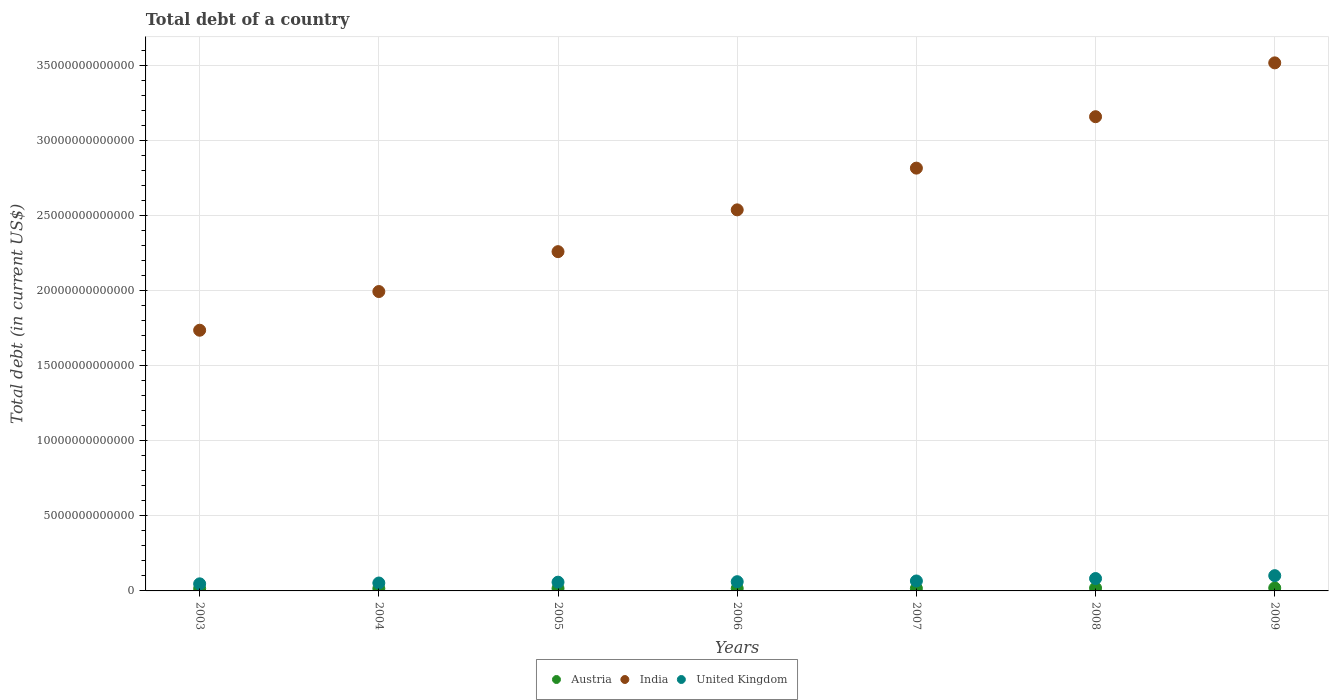How many different coloured dotlines are there?
Your answer should be very brief. 3. Is the number of dotlines equal to the number of legend labels?
Ensure brevity in your answer.  Yes. What is the debt in India in 2006?
Your answer should be compact. 2.54e+13. Across all years, what is the maximum debt in United Kingdom?
Ensure brevity in your answer.  1.02e+12. Across all years, what is the minimum debt in United Kingdom?
Offer a terse response. 4.72e+11. In which year was the debt in Austria maximum?
Provide a succinct answer. 2009. In which year was the debt in United Kingdom minimum?
Offer a very short reply. 2003. What is the total debt in India in the graph?
Make the answer very short. 1.80e+14. What is the difference between the debt in United Kingdom in 2003 and that in 2005?
Provide a short and direct response. -1.10e+11. What is the difference between the debt in United Kingdom in 2006 and the debt in India in 2003?
Make the answer very short. -1.68e+13. What is the average debt in India per year?
Give a very brief answer. 2.57e+13. In the year 2008, what is the difference between the debt in India and debt in Austria?
Make the answer very short. 3.14e+13. In how many years, is the debt in Austria greater than 23000000000000 US$?
Your answer should be very brief. 0. What is the ratio of the debt in India in 2007 to that in 2008?
Offer a terse response. 0.89. Is the debt in Austria in 2003 less than that in 2008?
Ensure brevity in your answer.  Yes. Is the difference between the debt in India in 2003 and 2005 greater than the difference between the debt in Austria in 2003 and 2005?
Provide a short and direct response. No. What is the difference between the highest and the second highest debt in Austria?
Give a very brief answer. 1.02e+1. What is the difference between the highest and the lowest debt in United Kingdom?
Provide a succinct answer. 5.44e+11. In how many years, is the debt in Austria greater than the average debt in Austria taken over all years?
Offer a very short reply. 2. Does the debt in United Kingdom monotonically increase over the years?
Make the answer very short. Yes. Is the debt in India strictly greater than the debt in Austria over the years?
Keep it short and to the point. Yes. How many dotlines are there?
Ensure brevity in your answer.  3. What is the difference between two consecutive major ticks on the Y-axis?
Your answer should be very brief. 5.00e+12. Does the graph contain grids?
Your answer should be very brief. Yes. How many legend labels are there?
Offer a terse response. 3. What is the title of the graph?
Your answer should be very brief. Total debt of a country. What is the label or title of the Y-axis?
Your answer should be compact. Total debt (in current US$). What is the Total debt (in current US$) in Austria in 2003?
Your response must be concise. 1.51e+11. What is the Total debt (in current US$) of India in 2003?
Provide a short and direct response. 1.74e+13. What is the Total debt (in current US$) in United Kingdom in 2003?
Give a very brief answer. 4.72e+11. What is the Total debt (in current US$) in Austria in 2004?
Your response must be concise. 1.57e+11. What is the Total debt (in current US$) of India in 2004?
Ensure brevity in your answer.  1.99e+13. What is the Total debt (in current US$) of United Kingdom in 2004?
Your answer should be very brief. 5.28e+11. What is the Total debt (in current US$) of Austria in 2005?
Provide a succinct answer. 1.66e+11. What is the Total debt (in current US$) of India in 2005?
Your answer should be very brief. 2.26e+13. What is the Total debt (in current US$) in United Kingdom in 2005?
Keep it short and to the point. 5.83e+11. What is the Total debt (in current US$) of Austria in 2006?
Make the answer very short. 1.65e+11. What is the Total debt (in current US$) of India in 2006?
Provide a short and direct response. 2.54e+13. What is the Total debt (in current US$) in United Kingdom in 2006?
Give a very brief answer. 6.15e+11. What is the Total debt (in current US$) in Austria in 2007?
Your answer should be very brief. 1.67e+11. What is the Total debt (in current US$) of India in 2007?
Your response must be concise. 2.82e+13. What is the Total debt (in current US$) in United Kingdom in 2007?
Give a very brief answer. 6.63e+11. What is the Total debt (in current US$) of Austria in 2008?
Your answer should be very brief. 1.87e+11. What is the Total debt (in current US$) in India in 2008?
Provide a short and direct response. 3.16e+13. What is the Total debt (in current US$) in United Kingdom in 2008?
Your answer should be compact. 8.25e+11. What is the Total debt (in current US$) in Austria in 2009?
Offer a very short reply. 1.97e+11. What is the Total debt (in current US$) of India in 2009?
Keep it short and to the point. 3.52e+13. What is the Total debt (in current US$) of United Kingdom in 2009?
Offer a terse response. 1.02e+12. Across all years, what is the maximum Total debt (in current US$) in Austria?
Ensure brevity in your answer.  1.97e+11. Across all years, what is the maximum Total debt (in current US$) in India?
Give a very brief answer. 3.52e+13. Across all years, what is the maximum Total debt (in current US$) of United Kingdom?
Ensure brevity in your answer.  1.02e+12. Across all years, what is the minimum Total debt (in current US$) of Austria?
Offer a very short reply. 1.51e+11. Across all years, what is the minimum Total debt (in current US$) in India?
Your answer should be very brief. 1.74e+13. Across all years, what is the minimum Total debt (in current US$) of United Kingdom?
Your answer should be very brief. 4.72e+11. What is the total Total debt (in current US$) in Austria in the graph?
Give a very brief answer. 1.19e+12. What is the total Total debt (in current US$) of India in the graph?
Offer a very short reply. 1.80e+14. What is the total Total debt (in current US$) in United Kingdom in the graph?
Keep it short and to the point. 4.70e+12. What is the difference between the Total debt (in current US$) in Austria in 2003 and that in 2004?
Keep it short and to the point. -6.16e+09. What is the difference between the Total debt (in current US$) of India in 2003 and that in 2004?
Your answer should be compact. -2.58e+12. What is the difference between the Total debt (in current US$) in United Kingdom in 2003 and that in 2004?
Ensure brevity in your answer.  -5.53e+1. What is the difference between the Total debt (in current US$) in Austria in 2003 and that in 2005?
Provide a succinct answer. -1.45e+1. What is the difference between the Total debt (in current US$) of India in 2003 and that in 2005?
Your answer should be very brief. -5.23e+12. What is the difference between the Total debt (in current US$) in United Kingdom in 2003 and that in 2005?
Give a very brief answer. -1.10e+11. What is the difference between the Total debt (in current US$) in Austria in 2003 and that in 2006?
Provide a succinct answer. -1.43e+1. What is the difference between the Total debt (in current US$) of India in 2003 and that in 2006?
Keep it short and to the point. -8.02e+12. What is the difference between the Total debt (in current US$) in United Kingdom in 2003 and that in 2006?
Provide a succinct answer. -1.42e+11. What is the difference between the Total debt (in current US$) of Austria in 2003 and that in 2007?
Provide a succinct answer. -1.55e+1. What is the difference between the Total debt (in current US$) of India in 2003 and that in 2007?
Ensure brevity in your answer.  -1.08e+13. What is the difference between the Total debt (in current US$) in United Kingdom in 2003 and that in 2007?
Your response must be concise. -1.91e+11. What is the difference between the Total debt (in current US$) of Austria in 2003 and that in 2008?
Your response must be concise. -3.62e+1. What is the difference between the Total debt (in current US$) of India in 2003 and that in 2008?
Offer a very short reply. -1.42e+13. What is the difference between the Total debt (in current US$) of United Kingdom in 2003 and that in 2008?
Your response must be concise. -3.53e+11. What is the difference between the Total debt (in current US$) in Austria in 2003 and that in 2009?
Your answer should be compact. -4.64e+1. What is the difference between the Total debt (in current US$) of India in 2003 and that in 2009?
Ensure brevity in your answer.  -1.78e+13. What is the difference between the Total debt (in current US$) of United Kingdom in 2003 and that in 2009?
Your answer should be compact. -5.44e+11. What is the difference between the Total debt (in current US$) of Austria in 2004 and that in 2005?
Give a very brief answer. -8.31e+09. What is the difference between the Total debt (in current US$) of India in 2004 and that in 2005?
Provide a short and direct response. -2.66e+12. What is the difference between the Total debt (in current US$) of United Kingdom in 2004 and that in 2005?
Provide a succinct answer. -5.50e+1. What is the difference between the Total debt (in current US$) in Austria in 2004 and that in 2006?
Provide a succinct answer. -8.10e+09. What is the difference between the Total debt (in current US$) in India in 2004 and that in 2006?
Ensure brevity in your answer.  -5.44e+12. What is the difference between the Total debt (in current US$) in United Kingdom in 2004 and that in 2006?
Your response must be concise. -8.70e+1. What is the difference between the Total debt (in current US$) of Austria in 2004 and that in 2007?
Keep it short and to the point. -9.38e+09. What is the difference between the Total debt (in current US$) in India in 2004 and that in 2007?
Provide a succinct answer. -8.22e+12. What is the difference between the Total debt (in current US$) in United Kingdom in 2004 and that in 2007?
Offer a very short reply. -1.35e+11. What is the difference between the Total debt (in current US$) in Austria in 2004 and that in 2008?
Offer a very short reply. -3.00e+1. What is the difference between the Total debt (in current US$) in India in 2004 and that in 2008?
Ensure brevity in your answer.  -1.16e+13. What is the difference between the Total debt (in current US$) of United Kingdom in 2004 and that in 2008?
Your answer should be compact. -2.98e+11. What is the difference between the Total debt (in current US$) of Austria in 2004 and that in 2009?
Your answer should be very brief. -4.02e+1. What is the difference between the Total debt (in current US$) of India in 2004 and that in 2009?
Keep it short and to the point. -1.52e+13. What is the difference between the Total debt (in current US$) in United Kingdom in 2004 and that in 2009?
Ensure brevity in your answer.  -4.89e+11. What is the difference between the Total debt (in current US$) of Austria in 2005 and that in 2006?
Your answer should be very brief. 2.14e+08. What is the difference between the Total debt (in current US$) in India in 2005 and that in 2006?
Your response must be concise. -2.78e+12. What is the difference between the Total debt (in current US$) of United Kingdom in 2005 and that in 2006?
Make the answer very short. -3.20e+1. What is the difference between the Total debt (in current US$) in Austria in 2005 and that in 2007?
Your response must be concise. -1.07e+09. What is the difference between the Total debt (in current US$) in India in 2005 and that in 2007?
Make the answer very short. -5.56e+12. What is the difference between the Total debt (in current US$) in United Kingdom in 2005 and that in 2007?
Make the answer very short. -8.05e+1. What is the difference between the Total debt (in current US$) in Austria in 2005 and that in 2008?
Keep it short and to the point. -2.17e+1. What is the difference between the Total debt (in current US$) in India in 2005 and that in 2008?
Make the answer very short. -8.99e+12. What is the difference between the Total debt (in current US$) in United Kingdom in 2005 and that in 2008?
Your response must be concise. -2.43e+11. What is the difference between the Total debt (in current US$) in Austria in 2005 and that in 2009?
Give a very brief answer. -3.19e+1. What is the difference between the Total debt (in current US$) of India in 2005 and that in 2009?
Make the answer very short. -1.26e+13. What is the difference between the Total debt (in current US$) in United Kingdom in 2005 and that in 2009?
Offer a terse response. -4.34e+11. What is the difference between the Total debt (in current US$) in Austria in 2006 and that in 2007?
Provide a short and direct response. -1.28e+09. What is the difference between the Total debt (in current US$) in India in 2006 and that in 2007?
Provide a succinct answer. -2.78e+12. What is the difference between the Total debt (in current US$) of United Kingdom in 2006 and that in 2007?
Your answer should be compact. -4.85e+1. What is the difference between the Total debt (in current US$) of Austria in 2006 and that in 2008?
Offer a very short reply. -2.19e+1. What is the difference between the Total debt (in current US$) of India in 2006 and that in 2008?
Provide a succinct answer. -6.21e+12. What is the difference between the Total debt (in current US$) of United Kingdom in 2006 and that in 2008?
Provide a short and direct response. -2.11e+11. What is the difference between the Total debt (in current US$) of Austria in 2006 and that in 2009?
Keep it short and to the point. -3.21e+1. What is the difference between the Total debt (in current US$) of India in 2006 and that in 2009?
Your answer should be compact. -9.79e+12. What is the difference between the Total debt (in current US$) in United Kingdom in 2006 and that in 2009?
Your answer should be very brief. -4.02e+11. What is the difference between the Total debt (in current US$) of Austria in 2007 and that in 2008?
Your response must be concise. -2.06e+1. What is the difference between the Total debt (in current US$) of India in 2007 and that in 2008?
Your answer should be compact. -3.43e+12. What is the difference between the Total debt (in current US$) of United Kingdom in 2007 and that in 2008?
Make the answer very short. -1.62e+11. What is the difference between the Total debt (in current US$) of Austria in 2007 and that in 2009?
Offer a very short reply. -3.08e+1. What is the difference between the Total debt (in current US$) in India in 2007 and that in 2009?
Provide a short and direct response. -7.01e+12. What is the difference between the Total debt (in current US$) in United Kingdom in 2007 and that in 2009?
Keep it short and to the point. -3.54e+11. What is the difference between the Total debt (in current US$) in Austria in 2008 and that in 2009?
Give a very brief answer. -1.02e+1. What is the difference between the Total debt (in current US$) of India in 2008 and that in 2009?
Your response must be concise. -3.59e+12. What is the difference between the Total debt (in current US$) in United Kingdom in 2008 and that in 2009?
Your response must be concise. -1.91e+11. What is the difference between the Total debt (in current US$) of Austria in 2003 and the Total debt (in current US$) of India in 2004?
Provide a short and direct response. -1.98e+13. What is the difference between the Total debt (in current US$) in Austria in 2003 and the Total debt (in current US$) in United Kingdom in 2004?
Offer a terse response. -3.77e+11. What is the difference between the Total debt (in current US$) in India in 2003 and the Total debt (in current US$) in United Kingdom in 2004?
Your answer should be very brief. 1.68e+13. What is the difference between the Total debt (in current US$) in Austria in 2003 and the Total debt (in current US$) in India in 2005?
Keep it short and to the point. -2.25e+13. What is the difference between the Total debt (in current US$) in Austria in 2003 and the Total debt (in current US$) in United Kingdom in 2005?
Provide a short and direct response. -4.32e+11. What is the difference between the Total debt (in current US$) of India in 2003 and the Total debt (in current US$) of United Kingdom in 2005?
Make the answer very short. 1.68e+13. What is the difference between the Total debt (in current US$) in Austria in 2003 and the Total debt (in current US$) in India in 2006?
Provide a succinct answer. -2.52e+13. What is the difference between the Total debt (in current US$) of Austria in 2003 and the Total debt (in current US$) of United Kingdom in 2006?
Your answer should be compact. -4.64e+11. What is the difference between the Total debt (in current US$) of India in 2003 and the Total debt (in current US$) of United Kingdom in 2006?
Your response must be concise. 1.68e+13. What is the difference between the Total debt (in current US$) in Austria in 2003 and the Total debt (in current US$) in India in 2007?
Offer a terse response. -2.80e+13. What is the difference between the Total debt (in current US$) of Austria in 2003 and the Total debt (in current US$) of United Kingdom in 2007?
Ensure brevity in your answer.  -5.12e+11. What is the difference between the Total debt (in current US$) in India in 2003 and the Total debt (in current US$) in United Kingdom in 2007?
Provide a short and direct response. 1.67e+13. What is the difference between the Total debt (in current US$) of Austria in 2003 and the Total debt (in current US$) of India in 2008?
Ensure brevity in your answer.  -3.14e+13. What is the difference between the Total debt (in current US$) in Austria in 2003 and the Total debt (in current US$) in United Kingdom in 2008?
Provide a short and direct response. -6.74e+11. What is the difference between the Total debt (in current US$) of India in 2003 and the Total debt (in current US$) of United Kingdom in 2008?
Offer a very short reply. 1.65e+13. What is the difference between the Total debt (in current US$) in Austria in 2003 and the Total debt (in current US$) in India in 2009?
Provide a succinct answer. -3.50e+13. What is the difference between the Total debt (in current US$) of Austria in 2003 and the Total debt (in current US$) of United Kingdom in 2009?
Ensure brevity in your answer.  -8.66e+11. What is the difference between the Total debt (in current US$) of India in 2003 and the Total debt (in current US$) of United Kingdom in 2009?
Offer a terse response. 1.64e+13. What is the difference between the Total debt (in current US$) of Austria in 2004 and the Total debt (in current US$) of India in 2005?
Keep it short and to the point. -2.24e+13. What is the difference between the Total debt (in current US$) of Austria in 2004 and the Total debt (in current US$) of United Kingdom in 2005?
Make the answer very short. -4.25e+11. What is the difference between the Total debt (in current US$) of India in 2004 and the Total debt (in current US$) of United Kingdom in 2005?
Offer a very short reply. 1.94e+13. What is the difference between the Total debt (in current US$) of Austria in 2004 and the Total debt (in current US$) of India in 2006?
Make the answer very short. -2.52e+13. What is the difference between the Total debt (in current US$) of Austria in 2004 and the Total debt (in current US$) of United Kingdom in 2006?
Keep it short and to the point. -4.57e+11. What is the difference between the Total debt (in current US$) in India in 2004 and the Total debt (in current US$) in United Kingdom in 2006?
Make the answer very short. 1.93e+13. What is the difference between the Total debt (in current US$) in Austria in 2004 and the Total debt (in current US$) in India in 2007?
Your answer should be very brief. -2.80e+13. What is the difference between the Total debt (in current US$) in Austria in 2004 and the Total debt (in current US$) in United Kingdom in 2007?
Offer a very short reply. -5.06e+11. What is the difference between the Total debt (in current US$) in India in 2004 and the Total debt (in current US$) in United Kingdom in 2007?
Provide a short and direct response. 1.93e+13. What is the difference between the Total debt (in current US$) in Austria in 2004 and the Total debt (in current US$) in India in 2008?
Your answer should be compact. -3.14e+13. What is the difference between the Total debt (in current US$) in Austria in 2004 and the Total debt (in current US$) in United Kingdom in 2008?
Give a very brief answer. -6.68e+11. What is the difference between the Total debt (in current US$) of India in 2004 and the Total debt (in current US$) of United Kingdom in 2008?
Keep it short and to the point. 1.91e+13. What is the difference between the Total debt (in current US$) of Austria in 2004 and the Total debt (in current US$) of India in 2009?
Provide a short and direct response. -3.50e+13. What is the difference between the Total debt (in current US$) of Austria in 2004 and the Total debt (in current US$) of United Kingdom in 2009?
Provide a succinct answer. -8.59e+11. What is the difference between the Total debt (in current US$) of India in 2004 and the Total debt (in current US$) of United Kingdom in 2009?
Provide a short and direct response. 1.89e+13. What is the difference between the Total debt (in current US$) in Austria in 2005 and the Total debt (in current US$) in India in 2006?
Give a very brief answer. -2.52e+13. What is the difference between the Total debt (in current US$) of Austria in 2005 and the Total debt (in current US$) of United Kingdom in 2006?
Provide a succinct answer. -4.49e+11. What is the difference between the Total debt (in current US$) in India in 2005 and the Total debt (in current US$) in United Kingdom in 2006?
Your response must be concise. 2.20e+13. What is the difference between the Total debt (in current US$) in Austria in 2005 and the Total debt (in current US$) in India in 2007?
Offer a terse response. -2.80e+13. What is the difference between the Total debt (in current US$) of Austria in 2005 and the Total debt (in current US$) of United Kingdom in 2007?
Give a very brief answer. -4.98e+11. What is the difference between the Total debt (in current US$) in India in 2005 and the Total debt (in current US$) in United Kingdom in 2007?
Your response must be concise. 2.19e+13. What is the difference between the Total debt (in current US$) in Austria in 2005 and the Total debt (in current US$) in India in 2008?
Provide a short and direct response. -3.14e+13. What is the difference between the Total debt (in current US$) of Austria in 2005 and the Total debt (in current US$) of United Kingdom in 2008?
Ensure brevity in your answer.  -6.60e+11. What is the difference between the Total debt (in current US$) in India in 2005 and the Total debt (in current US$) in United Kingdom in 2008?
Provide a short and direct response. 2.18e+13. What is the difference between the Total debt (in current US$) in Austria in 2005 and the Total debt (in current US$) in India in 2009?
Ensure brevity in your answer.  -3.50e+13. What is the difference between the Total debt (in current US$) of Austria in 2005 and the Total debt (in current US$) of United Kingdom in 2009?
Ensure brevity in your answer.  -8.51e+11. What is the difference between the Total debt (in current US$) of India in 2005 and the Total debt (in current US$) of United Kingdom in 2009?
Give a very brief answer. 2.16e+13. What is the difference between the Total debt (in current US$) in Austria in 2006 and the Total debt (in current US$) in India in 2007?
Your answer should be compact. -2.80e+13. What is the difference between the Total debt (in current US$) in Austria in 2006 and the Total debt (in current US$) in United Kingdom in 2007?
Your answer should be very brief. -4.98e+11. What is the difference between the Total debt (in current US$) in India in 2006 and the Total debt (in current US$) in United Kingdom in 2007?
Keep it short and to the point. 2.47e+13. What is the difference between the Total debt (in current US$) of Austria in 2006 and the Total debt (in current US$) of India in 2008?
Ensure brevity in your answer.  -3.14e+13. What is the difference between the Total debt (in current US$) of Austria in 2006 and the Total debt (in current US$) of United Kingdom in 2008?
Keep it short and to the point. -6.60e+11. What is the difference between the Total debt (in current US$) of India in 2006 and the Total debt (in current US$) of United Kingdom in 2008?
Your answer should be very brief. 2.46e+13. What is the difference between the Total debt (in current US$) of Austria in 2006 and the Total debt (in current US$) of India in 2009?
Your answer should be very brief. -3.50e+13. What is the difference between the Total debt (in current US$) in Austria in 2006 and the Total debt (in current US$) in United Kingdom in 2009?
Provide a short and direct response. -8.51e+11. What is the difference between the Total debt (in current US$) of India in 2006 and the Total debt (in current US$) of United Kingdom in 2009?
Offer a terse response. 2.44e+13. What is the difference between the Total debt (in current US$) in Austria in 2007 and the Total debt (in current US$) in India in 2008?
Provide a short and direct response. -3.14e+13. What is the difference between the Total debt (in current US$) of Austria in 2007 and the Total debt (in current US$) of United Kingdom in 2008?
Provide a short and direct response. -6.59e+11. What is the difference between the Total debt (in current US$) of India in 2007 and the Total debt (in current US$) of United Kingdom in 2008?
Give a very brief answer. 2.73e+13. What is the difference between the Total debt (in current US$) in Austria in 2007 and the Total debt (in current US$) in India in 2009?
Provide a succinct answer. -3.50e+13. What is the difference between the Total debt (in current US$) in Austria in 2007 and the Total debt (in current US$) in United Kingdom in 2009?
Provide a short and direct response. -8.50e+11. What is the difference between the Total debt (in current US$) in India in 2007 and the Total debt (in current US$) in United Kingdom in 2009?
Offer a very short reply. 2.71e+13. What is the difference between the Total debt (in current US$) in Austria in 2008 and the Total debt (in current US$) in India in 2009?
Give a very brief answer. -3.50e+13. What is the difference between the Total debt (in current US$) in Austria in 2008 and the Total debt (in current US$) in United Kingdom in 2009?
Ensure brevity in your answer.  -8.29e+11. What is the difference between the Total debt (in current US$) in India in 2008 and the Total debt (in current US$) in United Kingdom in 2009?
Provide a succinct answer. 3.06e+13. What is the average Total debt (in current US$) of Austria per year?
Give a very brief answer. 1.70e+11. What is the average Total debt (in current US$) of India per year?
Your answer should be compact. 2.57e+13. What is the average Total debt (in current US$) of United Kingdom per year?
Ensure brevity in your answer.  6.72e+11. In the year 2003, what is the difference between the Total debt (in current US$) in Austria and Total debt (in current US$) in India?
Keep it short and to the point. -1.72e+13. In the year 2003, what is the difference between the Total debt (in current US$) in Austria and Total debt (in current US$) in United Kingdom?
Provide a short and direct response. -3.21e+11. In the year 2003, what is the difference between the Total debt (in current US$) in India and Total debt (in current US$) in United Kingdom?
Ensure brevity in your answer.  1.69e+13. In the year 2004, what is the difference between the Total debt (in current US$) of Austria and Total debt (in current US$) of India?
Ensure brevity in your answer.  -1.98e+13. In the year 2004, what is the difference between the Total debt (in current US$) of Austria and Total debt (in current US$) of United Kingdom?
Make the answer very short. -3.70e+11. In the year 2004, what is the difference between the Total debt (in current US$) in India and Total debt (in current US$) in United Kingdom?
Keep it short and to the point. 1.94e+13. In the year 2005, what is the difference between the Total debt (in current US$) of Austria and Total debt (in current US$) of India?
Keep it short and to the point. -2.24e+13. In the year 2005, what is the difference between the Total debt (in current US$) in Austria and Total debt (in current US$) in United Kingdom?
Make the answer very short. -4.17e+11. In the year 2005, what is the difference between the Total debt (in current US$) in India and Total debt (in current US$) in United Kingdom?
Your answer should be very brief. 2.20e+13. In the year 2006, what is the difference between the Total debt (in current US$) in Austria and Total debt (in current US$) in India?
Offer a terse response. -2.52e+13. In the year 2006, what is the difference between the Total debt (in current US$) in Austria and Total debt (in current US$) in United Kingdom?
Give a very brief answer. -4.49e+11. In the year 2006, what is the difference between the Total debt (in current US$) in India and Total debt (in current US$) in United Kingdom?
Offer a very short reply. 2.48e+13. In the year 2007, what is the difference between the Total debt (in current US$) in Austria and Total debt (in current US$) in India?
Offer a very short reply. -2.80e+13. In the year 2007, what is the difference between the Total debt (in current US$) of Austria and Total debt (in current US$) of United Kingdom?
Your answer should be very brief. -4.97e+11. In the year 2007, what is the difference between the Total debt (in current US$) in India and Total debt (in current US$) in United Kingdom?
Ensure brevity in your answer.  2.75e+13. In the year 2008, what is the difference between the Total debt (in current US$) of Austria and Total debt (in current US$) of India?
Your answer should be compact. -3.14e+13. In the year 2008, what is the difference between the Total debt (in current US$) in Austria and Total debt (in current US$) in United Kingdom?
Keep it short and to the point. -6.38e+11. In the year 2008, what is the difference between the Total debt (in current US$) of India and Total debt (in current US$) of United Kingdom?
Give a very brief answer. 3.08e+13. In the year 2009, what is the difference between the Total debt (in current US$) of Austria and Total debt (in current US$) of India?
Ensure brevity in your answer.  -3.50e+13. In the year 2009, what is the difference between the Total debt (in current US$) of Austria and Total debt (in current US$) of United Kingdom?
Provide a succinct answer. -8.19e+11. In the year 2009, what is the difference between the Total debt (in current US$) in India and Total debt (in current US$) in United Kingdom?
Your answer should be compact. 3.42e+13. What is the ratio of the Total debt (in current US$) of Austria in 2003 to that in 2004?
Your response must be concise. 0.96. What is the ratio of the Total debt (in current US$) of India in 2003 to that in 2004?
Give a very brief answer. 0.87. What is the ratio of the Total debt (in current US$) in United Kingdom in 2003 to that in 2004?
Provide a short and direct response. 0.9. What is the ratio of the Total debt (in current US$) in Austria in 2003 to that in 2005?
Your answer should be very brief. 0.91. What is the ratio of the Total debt (in current US$) in India in 2003 to that in 2005?
Provide a short and direct response. 0.77. What is the ratio of the Total debt (in current US$) in United Kingdom in 2003 to that in 2005?
Make the answer very short. 0.81. What is the ratio of the Total debt (in current US$) in Austria in 2003 to that in 2006?
Offer a very short reply. 0.91. What is the ratio of the Total debt (in current US$) in India in 2003 to that in 2006?
Provide a short and direct response. 0.68. What is the ratio of the Total debt (in current US$) in United Kingdom in 2003 to that in 2006?
Provide a succinct answer. 0.77. What is the ratio of the Total debt (in current US$) in Austria in 2003 to that in 2007?
Give a very brief answer. 0.91. What is the ratio of the Total debt (in current US$) in India in 2003 to that in 2007?
Your answer should be very brief. 0.62. What is the ratio of the Total debt (in current US$) in United Kingdom in 2003 to that in 2007?
Your answer should be very brief. 0.71. What is the ratio of the Total debt (in current US$) of Austria in 2003 to that in 2008?
Your answer should be very brief. 0.81. What is the ratio of the Total debt (in current US$) of India in 2003 to that in 2008?
Provide a short and direct response. 0.55. What is the ratio of the Total debt (in current US$) in United Kingdom in 2003 to that in 2008?
Your answer should be compact. 0.57. What is the ratio of the Total debt (in current US$) in Austria in 2003 to that in 2009?
Provide a short and direct response. 0.77. What is the ratio of the Total debt (in current US$) of India in 2003 to that in 2009?
Provide a short and direct response. 0.49. What is the ratio of the Total debt (in current US$) of United Kingdom in 2003 to that in 2009?
Ensure brevity in your answer.  0.46. What is the ratio of the Total debt (in current US$) in Austria in 2004 to that in 2005?
Ensure brevity in your answer.  0.95. What is the ratio of the Total debt (in current US$) of India in 2004 to that in 2005?
Your response must be concise. 0.88. What is the ratio of the Total debt (in current US$) in United Kingdom in 2004 to that in 2005?
Ensure brevity in your answer.  0.91. What is the ratio of the Total debt (in current US$) of Austria in 2004 to that in 2006?
Keep it short and to the point. 0.95. What is the ratio of the Total debt (in current US$) in India in 2004 to that in 2006?
Offer a terse response. 0.79. What is the ratio of the Total debt (in current US$) of United Kingdom in 2004 to that in 2006?
Your answer should be compact. 0.86. What is the ratio of the Total debt (in current US$) in Austria in 2004 to that in 2007?
Keep it short and to the point. 0.94. What is the ratio of the Total debt (in current US$) in India in 2004 to that in 2007?
Ensure brevity in your answer.  0.71. What is the ratio of the Total debt (in current US$) in United Kingdom in 2004 to that in 2007?
Give a very brief answer. 0.8. What is the ratio of the Total debt (in current US$) in Austria in 2004 to that in 2008?
Your answer should be very brief. 0.84. What is the ratio of the Total debt (in current US$) in India in 2004 to that in 2008?
Provide a succinct answer. 0.63. What is the ratio of the Total debt (in current US$) of United Kingdom in 2004 to that in 2008?
Your answer should be compact. 0.64. What is the ratio of the Total debt (in current US$) of Austria in 2004 to that in 2009?
Keep it short and to the point. 0.8. What is the ratio of the Total debt (in current US$) in India in 2004 to that in 2009?
Give a very brief answer. 0.57. What is the ratio of the Total debt (in current US$) of United Kingdom in 2004 to that in 2009?
Offer a terse response. 0.52. What is the ratio of the Total debt (in current US$) in India in 2005 to that in 2006?
Provide a short and direct response. 0.89. What is the ratio of the Total debt (in current US$) of United Kingdom in 2005 to that in 2006?
Keep it short and to the point. 0.95. What is the ratio of the Total debt (in current US$) of Austria in 2005 to that in 2007?
Give a very brief answer. 0.99. What is the ratio of the Total debt (in current US$) in India in 2005 to that in 2007?
Provide a succinct answer. 0.8. What is the ratio of the Total debt (in current US$) of United Kingdom in 2005 to that in 2007?
Your answer should be very brief. 0.88. What is the ratio of the Total debt (in current US$) in Austria in 2005 to that in 2008?
Offer a very short reply. 0.88. What is the ratio of the Total debt (in current US$) of India in 2005 to that in 2008?
Offer a terse response. 0.72. What is the ratio of the Total debt (in current US$) in United Kingdom in 2005 to that in 2008?
Keep it short and to the point. 0.71. What is the ratio of the Total debt (in current US$) in Austria in 2005 to that in 2009?
Provide a short and direct response. 0.84. What is the ratio of the Total debt (in current US$) of India in 2005 to that in 2009?
Make the answer very short. 0.64. What is the ratio of the Total debt (in current US$) in United Kingdom in 2005 to that in 2009?
Make the answer very short. 0.57. What is the ratio of the Total debt (in current US$) in Austria in 2006 to that in 2007?
Provide a succinct answer. 0.99. What is the ratio of the Total debt (in current US$) in India in 2006 to that in 2007?
Your response must be concise. 0.9. What is the ratio of the Total debt (in current US$) in United Kingdom in 2006 to that in 2007?
Keep it short and to the point. 0.93. What is the ratio of the Total debt (in current US$) of Austria in 2006 to that in 2008?
Keep it short and to the point. 0.88. What is the ratio of the Total debt (in current US$) in India in 2006 to that in 2008?
Provide a short and direct response. 0.8. What is the ratio of the Total debt (in current US$) in United Kingdom in 2006 to that in 2008?
Give a very brief answer. 0.74. What is the ratio of the Total debt (in current US$) in Austria in 2006 to that in 2009?
Give a very brief answer. 0.84. What is the ratio of the Total debt (in current US$) in India in 2006 to that in 2009?
Provide a short and direct response. 0.72. What is the ratio of the Total debt (in current US$) of United Kingdom in 2006 to that in 2009?
Ensure brevity in your answer.  0.6. What is the ratio of the Total debt (in current US$) of Austria in 2007 to that in 2008?
Offer a terse response. 0.89. What is the ratio of the Total debt (in current US$) in India in 2007 to that in 2008?
Provide a succinct answer. 0.89. What is the ratio of the Total debt (in current US$) of United Kingdom in 2007 to that in 2008?
Keep it short and to the point. 0.8. What is the ratio of the Total debt (in current US$) of Austria in 2007 to that in 2009?
Your response must be concise. 0.84. What is the ratio of the Total debt (in current US$) of India in 2007 to that in 2009?
Offer a terse response. 0.8. What is the ratio of the Total debt (in current US$) in United Kingdom in 2007 to that in 2009?
Your answer should be compact. 0.65. What is the ratio of the Total debt (in current US$) in Austria in 2008 to that in 2009?
Keep it short and to the point. 0.95. What is the ratio of the Total debt (in current US$) in India in 2008 to that in 2009?
Provide a succinct answer. 0.9. What is the ratio of the Total debt (in current US$) in United Kingdom in 2008 to that in 2009?
Make the answer very short. 0.81. What is the difference between the highest and the second highest Total debt (in current US$) of Austria?
Make the answer very short. 1.02e+1. What is the difference between the highest and the second highest Total debt (in current US$) in India?
Your response must be concise. 3.59e+12. What is the difference between the highest and the second highest Total debt (in current US$) in United Kingdom?
Your answer should be compact. 1.91e+11. What is the difference between the highest and the lowest Total debt (in current US$) of Austria?
Your response must be concise. 4.64e+1. What is the difference between the highest and the lowest Total debt (in current US$) in India?
Give a very brief answer. 1.78e+13. What is the difference between the highest and the lowest Total debt (in current US$) of United Kingdom?
Your response must be concise. 5.44e+11. 